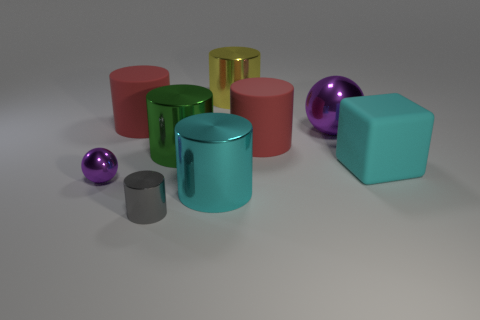Subtract all gray cylinders. How many cylinders are left? 5 Subtract all big cyan cylinders. How many cylinders are left? 5 Subtract 1 cylinders. How many cylinders are left? 5 Subtract all green cylinders. Subtract all yellow spheres. How many cylinders are left? 5 Add 1 large things. How many objects exist? 10 Subtract all cylinders. How many objects are left? 3 Add 1 yellow objects. How many yellow objects are left? 2 Add 5 big green things. How many big green things exist? 6 Subtract 0 brown cylinders. How many objects are left? 9 Subtract all small blue things. Subtract all cyan metallic cylinders. How many objects are left? 8 